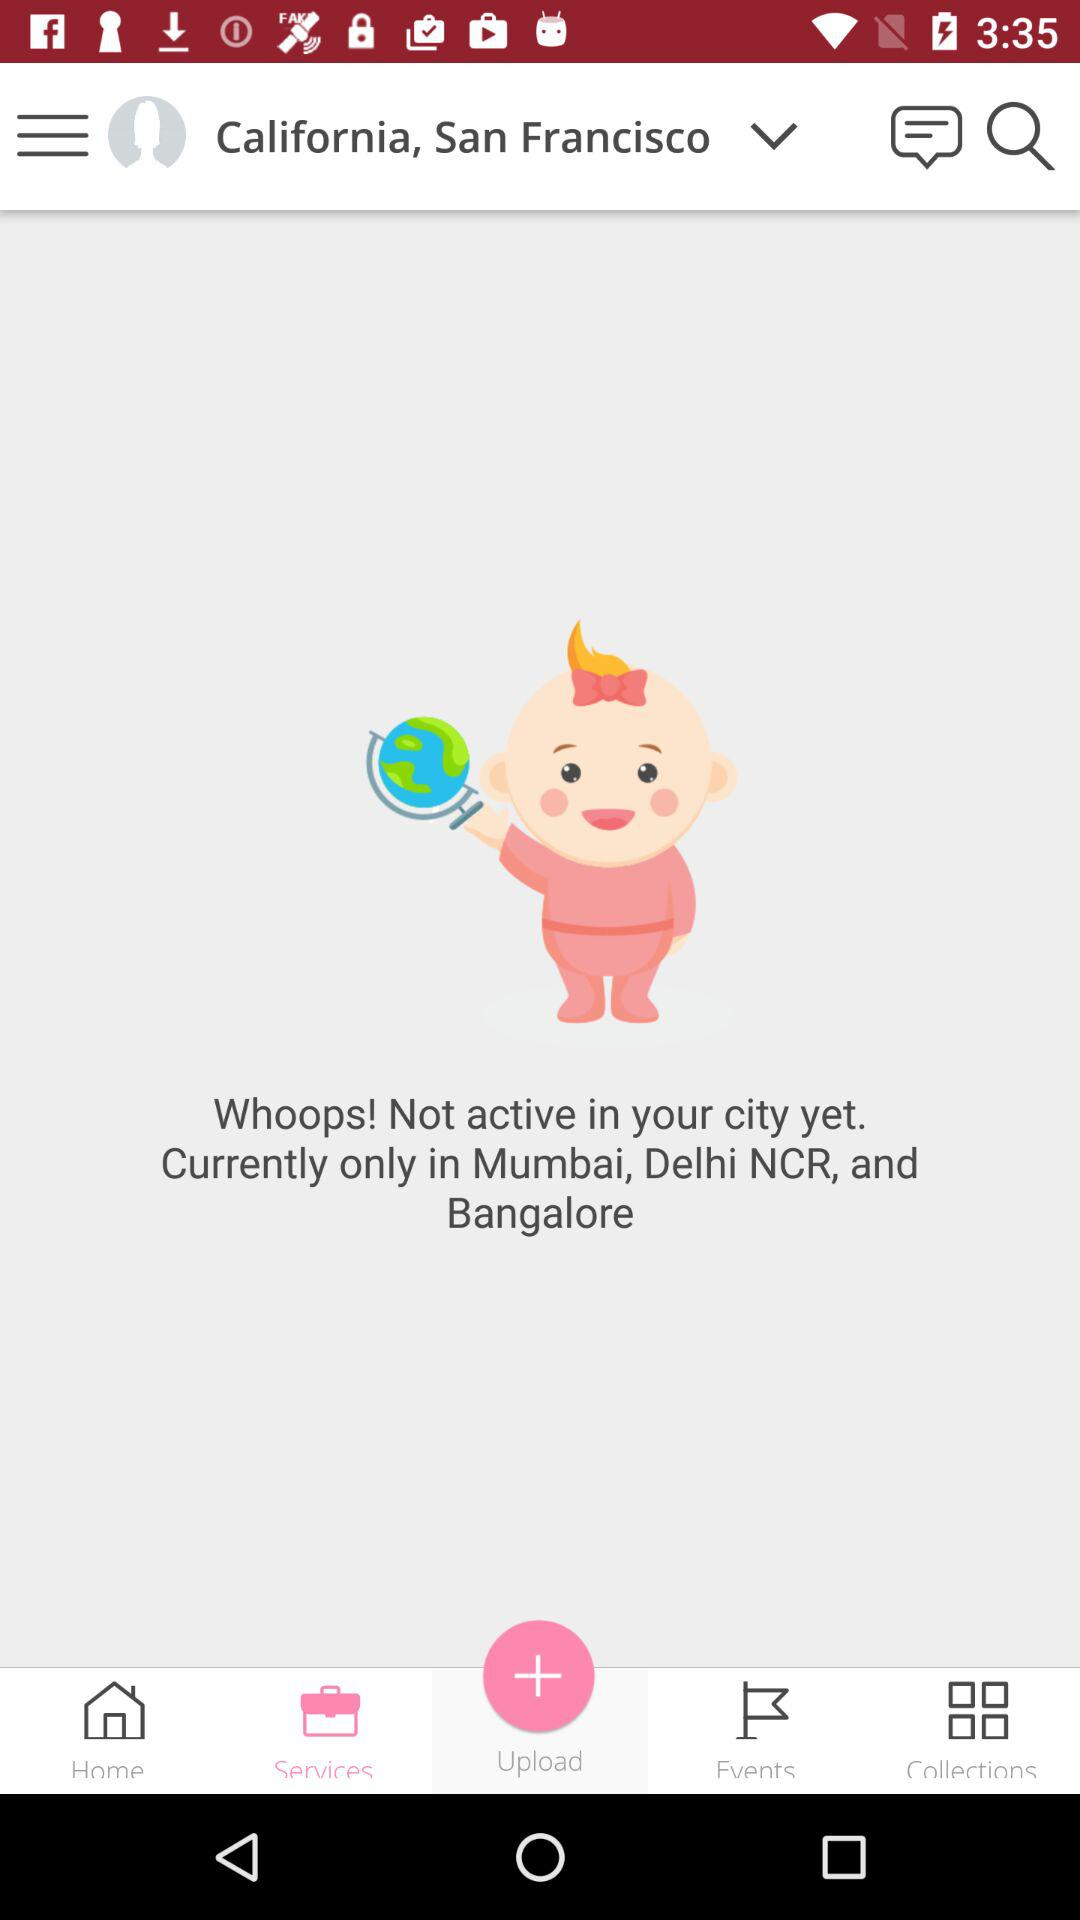How many cities are mentioned?
Answer the question using a single word or phrase. 3 